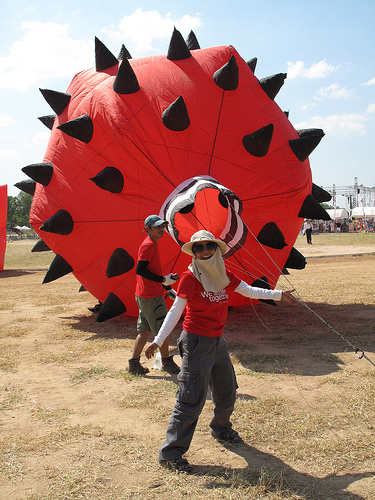<image>
Can you confirm if the spike is on the balloon? Yes. Looking at the image, I can see the spike is positioned on top of the balloon, with the balloon providing support. 